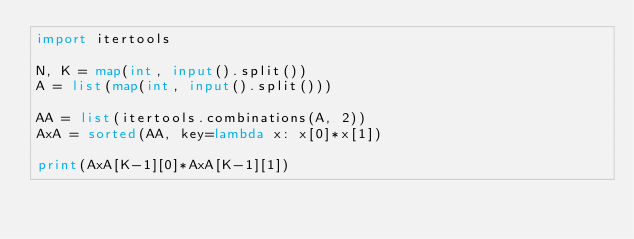Convert code to text. <code><loc_0><loc_0><loc_500><loc_500><_Python_>import itertools

N, K = map(int, input().split())
A = list(map(int, input().split()))

AA = list(itertools.combinations(A, 2))
AxA = sorted(AA, key=lambda x: x[0]*x[1])

print(AxA[K-1][0]*AxA[K-1][1])</code> 